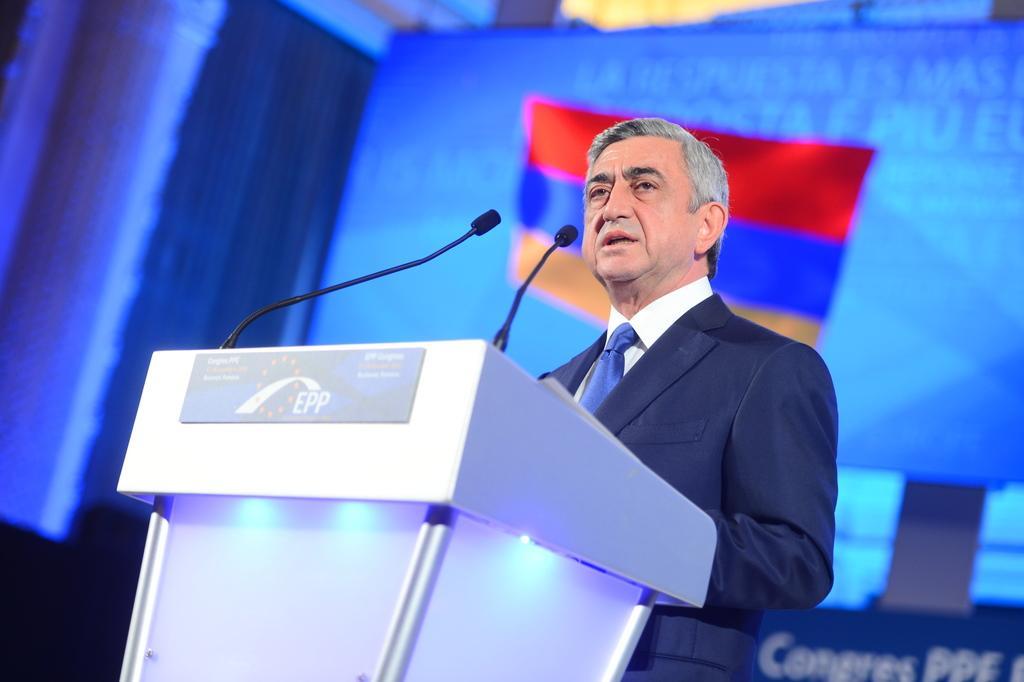In one or two sentences, can you explain what this image depicts? In this image we can see a person, he is talking, in front of him there is a podium, on that there is a board with some text on it, there are two mics, behind to him we can see the screen, a flag, and a poster with some text on it, the background is blurred. 